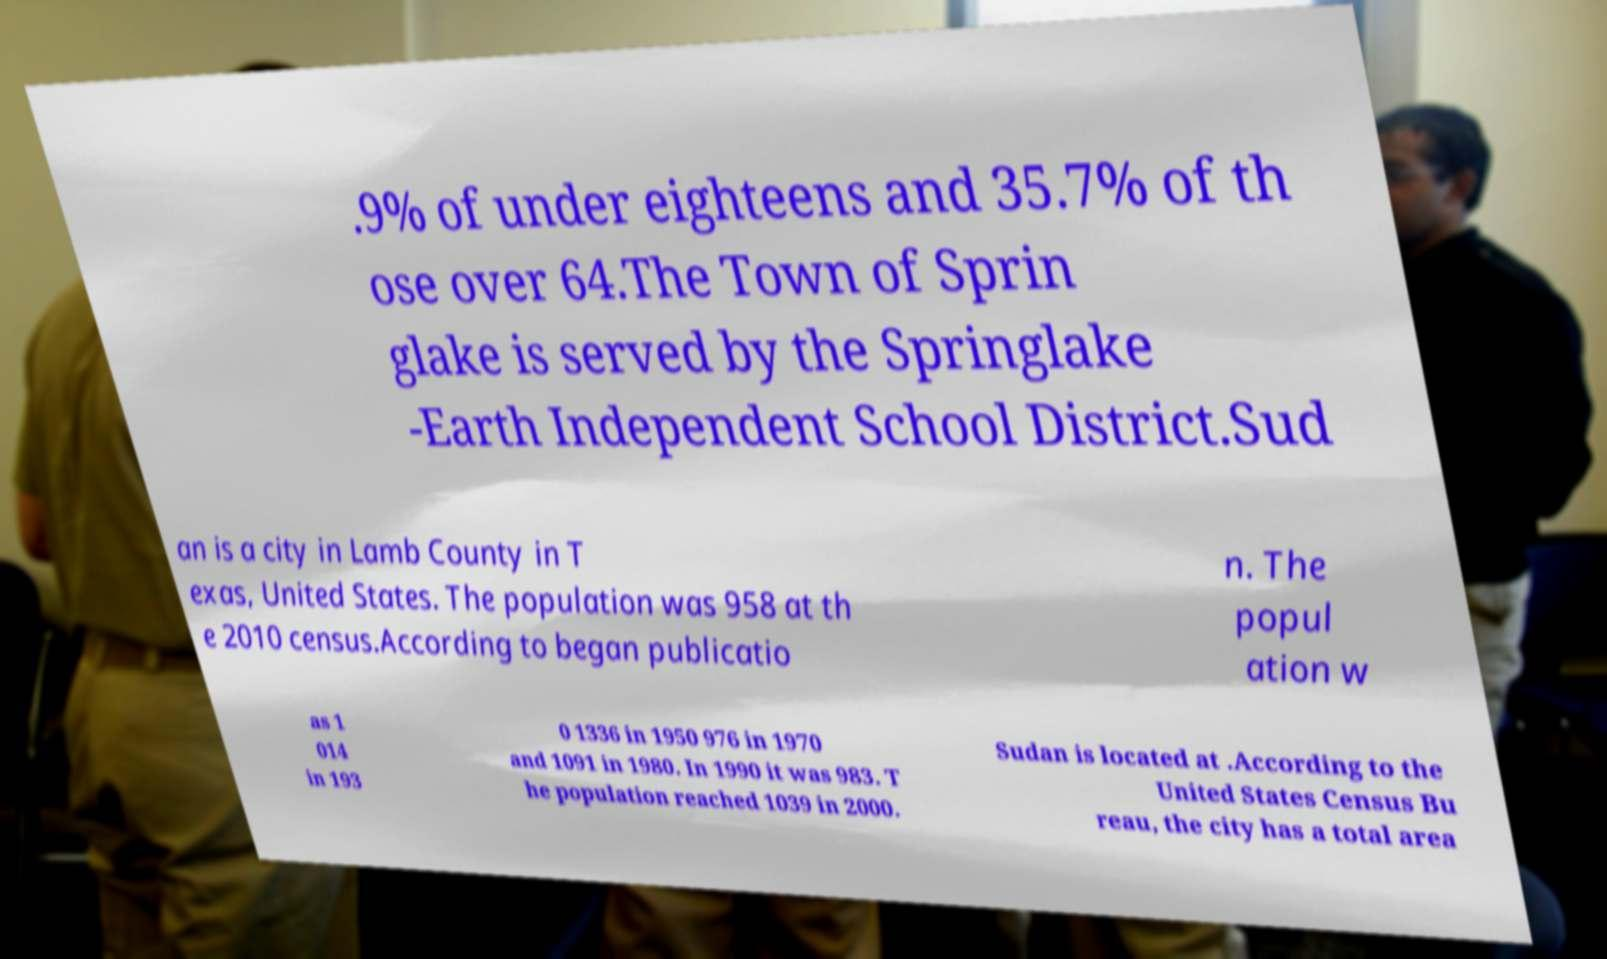I need the written content from this picture converted into text. Can you do that? .9% of under eighteens and 35.7% of th ose over 64.The Town of Sprin glake is served by the Springlake -Earth Independent School District.Sud an is a city in Lamb County in T exas, United States. The population was 958 at th e 2010 census.According to began publicatio n. The popul ation w as 1 014 in 193 0 1336 in 1950 976 in 1970 and 1091 in 1980. In 1990 it was 983. T he population reached 1039 in 2000. Sudan is located at .According to the United States Census Bu reau, the city has a total area 